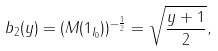Convert formula to latex. <formula><loc_0><loc_0><loc_500><loc_500>b _ { 2 } ( y ) = ( M ( 1 _ { I _ { 0 } } ) ) ^ { - \frac { 1 } { 2 } } = \sqrt { \frac { y + 1 } 2 } ,</formula> 